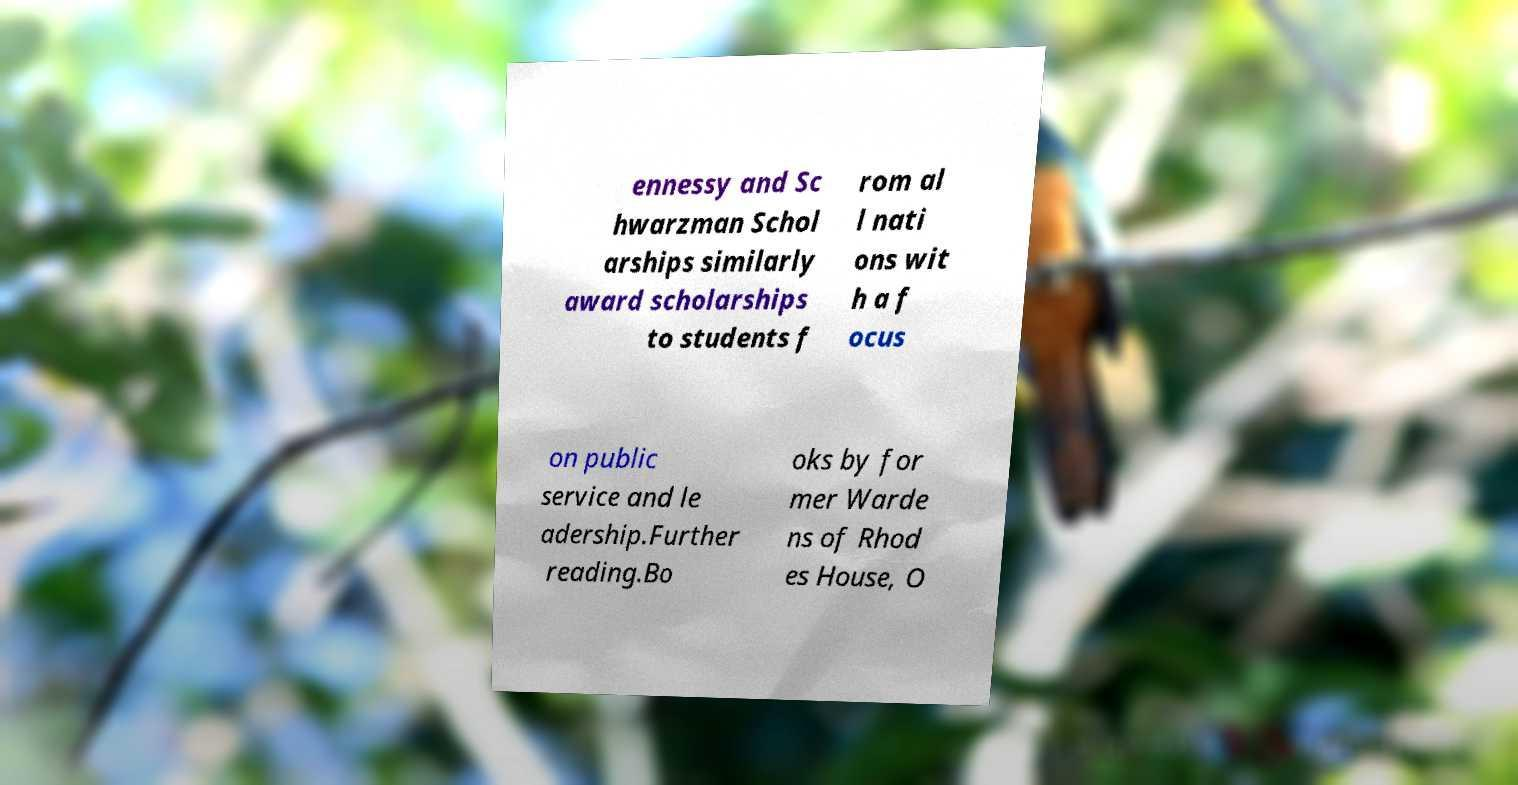There's text embedded in this image that I need extracted. Can you transcribe it verbatim? ennessy and Sc hwarzman Schol arships similarly award scholarships to students f rom al l nati ons wit h a f ocus on public service and le adership.Further reading.Bo oks by for mer Warde ns of Rhod es House, O 